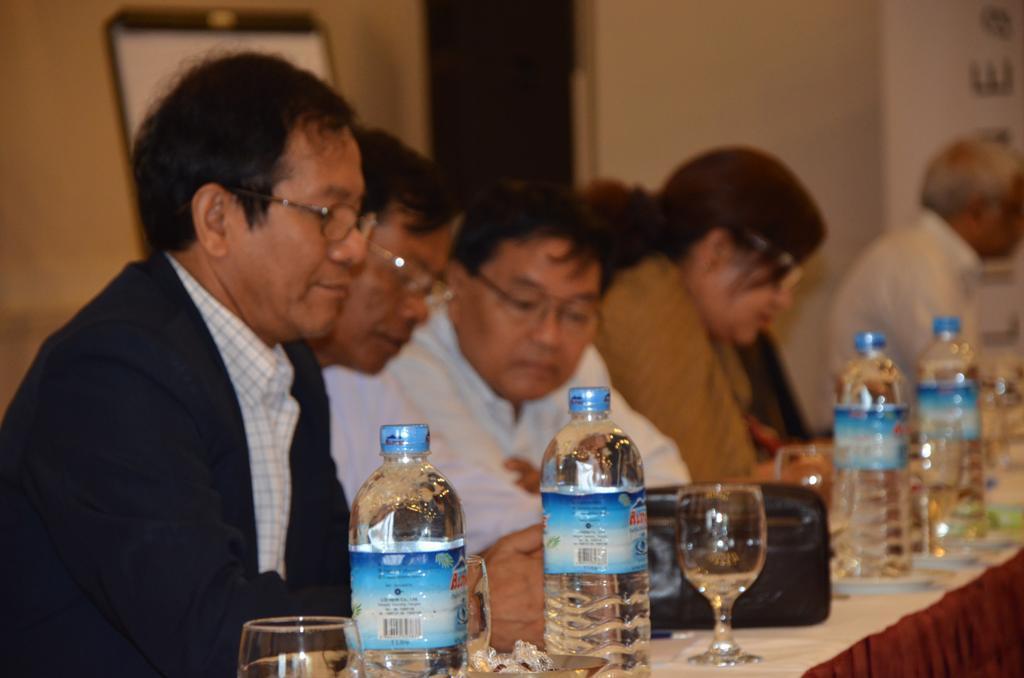Can you describe this image briefly? A group of people are sitting at a table. There are some bottles and water glasses on the table. 